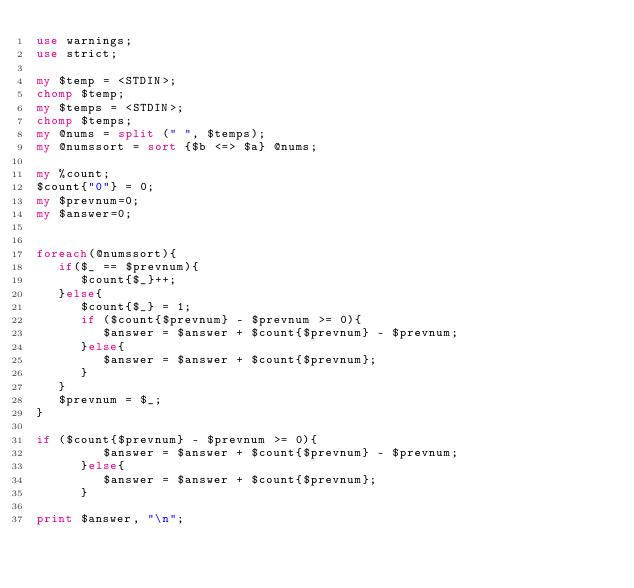Convert code to text. <code><loc_0><loc_0><loc_500><loc_500><_Perl_>use warnings;
use strict;

my $temp = <STDIN>;
chomp $temp;
my $temps = <STDIN>;
chomp $temps;
my @nums = split (" ", $temps);
my @numssort = sort {$b <=> $a} @nums;

my %count;
$count{"0"} = 0;
my $prevnum=0;
my $answer=0;


foreach(@numssort){
   if($_ == $prevnum){
      $count{$_}++;
   }else{
      $count{$_} = 1;
      if ($count{$prevnum} - $prevnum >= 0){
         $answer = $answer + $count{$prevnum} - $prevnum;
      }else{
         $answer = $answer + $count{$prevnum};
      }
   }
   $prevnum = $_;
}

if ($count{$prevnum} - $prevnum >= 0){
         $answer = $answer + $count{$prevnum} - $prevnum;
      }else{
         $answer = $answer + $count{$prevnum};
      }

print $answer, "\n";</code> 